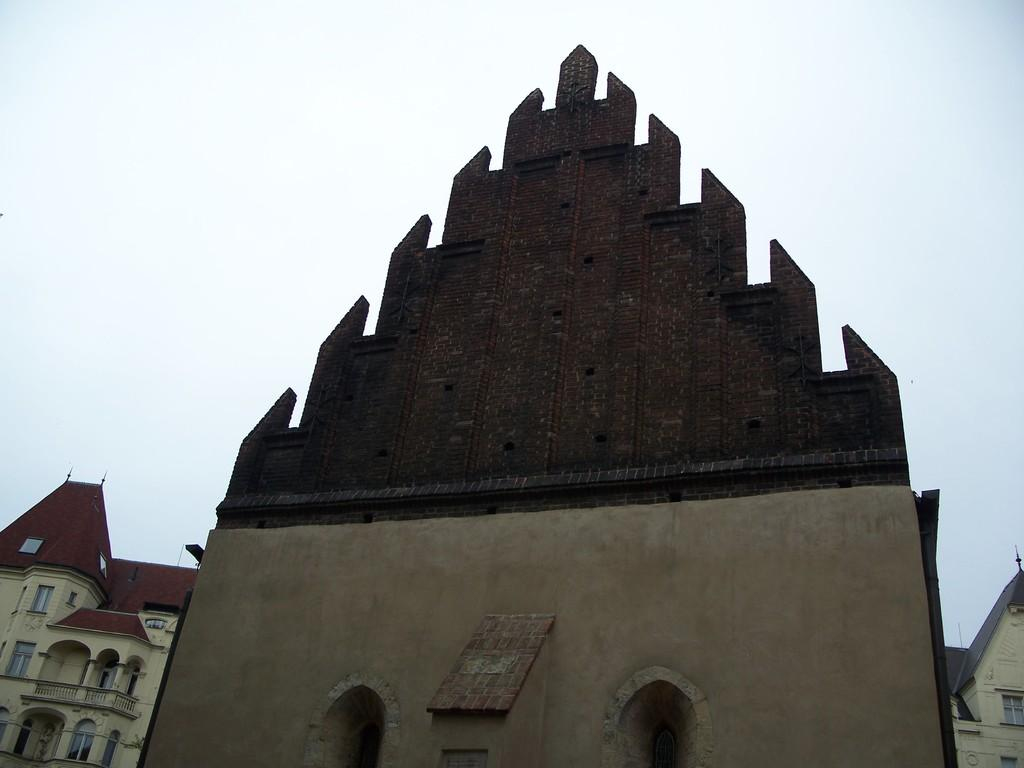What type of structures can be seen in the image? There are buildings in the image. What part of the natural environment is visible in the image? The sky is visible in the background of the image. What type of polish is being applied to the buildings in the image? There is no indication in the image that any polish is being applied to the buildings. 